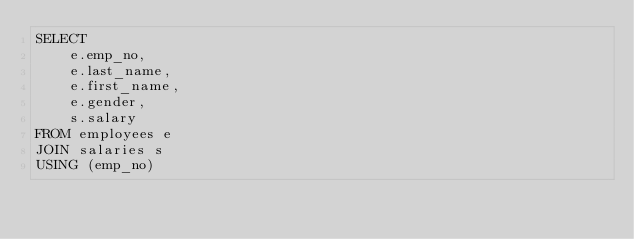Convert code to text. <code><loc_0><loc_0><loc_500><loc_500><_SQL_>SELECT 
    e.emp_no,
    e.last_name,
    e.first_name,
    e.gender,
    s.salary
FROM employees e
JOIN salaries s
USING (emp_no)
</code> 